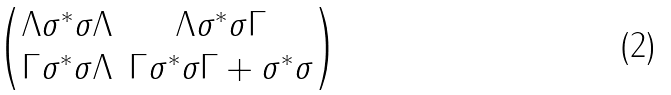Convert formula to latex. <formula><loc_0><loc_0><loc_500><loc_500>\begin{pmatrix} \Lambda \sigma ^ { * } \sigma \Lambda & \Lambda \sigma ^ { * } \sigma \Gamma \\ \Gamma \sigma ^ { * } \sigma \Lambda & \Gamma \sigma ^ { * } \sigma \Gamma + \sigma ^ { * } \sigma \end{pmatrix}</formula> 